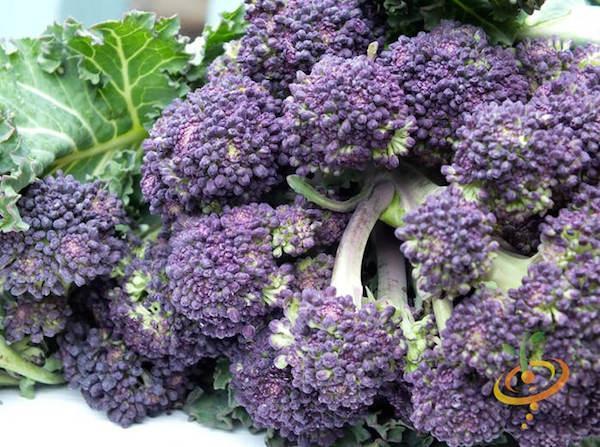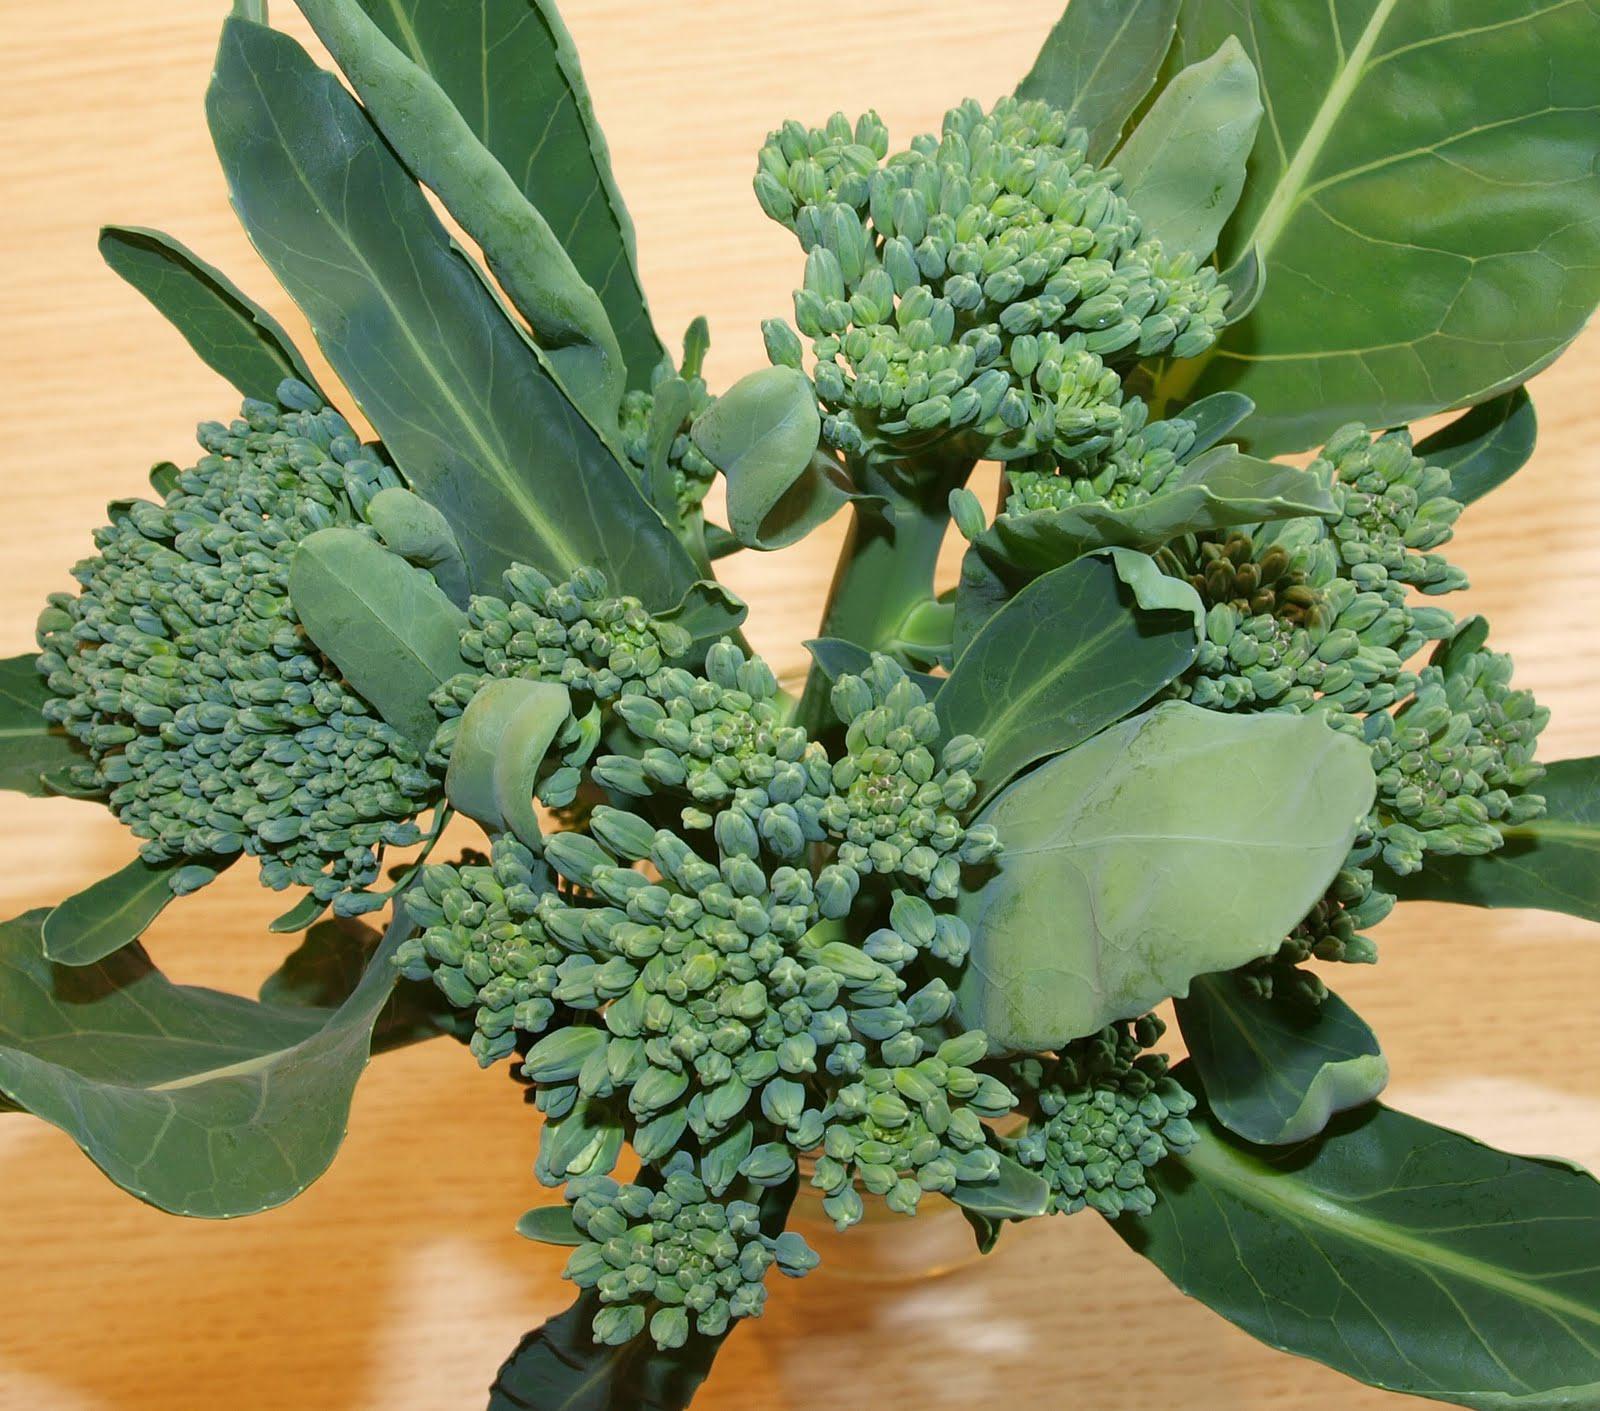The first image is the image on the left, the second image is the image on the right. For the images displayed, is the sentence "Broccoli is shown in both images, but in one it is a plant in the garden and in the other, it is cleaned for eating or cooking." factually correct? Answer yes or no. No. The first image is the image on the left, the second image is the image on the right. For the images shown, is this caption "An image shows broccoli growing in soil, with leaves surrounding the florets." true? Answer yes or no. No. 